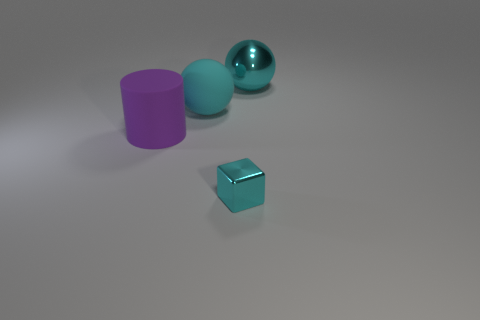Add 3 big cylinders. How many objects exist? 7 Subtract all blocks. How many objects are left? 3 Add 3 red shiny cylinders. How many red shiny cylinders exist? 3 Subtract 0 yellow cubes. How many objects are left? 4 Subtract all large rubber cylinders. Subtract all big purple matte objects. How many objects are left? 2 Add 2 large shiny balls. How many large shiny balls are left? 3 